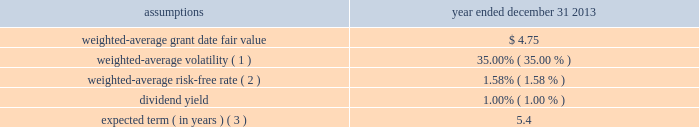Cdw corporation and subsidiaries notes to consolidated financial statements holders of class b common units in connection with the distribution is subject to any vesting provisions previously applicable to the holder 2019s class b common units .
Class b common unit holders received 3798508 shares of restricted stock with respect to class b common units that had not yet vested at the time of the distribution .
For the year ended december 31 , 2013 , 1200544 shares of such restricted stock vested/settled and 5931 shares were forfeited .
As of december 31 , 2013 , 2592033 shares of restricted stock were outstanding .
Stock options in addition , in connection with the ipo , the company issued 1268986 stock options to the class b common unit holders to preserve their fully diluted equity ownership percentage .
These options were issued with a per-share exercise price equal to the ipo price of $ 17.00 and are also subject to the same vesting provisions as the class b common units to which they relate .
The company also granted 19412 stock options under the 2013 ltip during the year ended december 31 , 2013 .
Restricted stock units ( 201crsus 201d ) in connection with the ipo , the company granted 1416543 rsus under the 2013 ltip at a weighted- average grant-date fair value of $ 17.03 per unit .
The rsus cliff-vest at the end of four years .
Valuation information the company attributes the value of equity-based compensation awards to the various periods during which the recipient must perform services in order to vest in the award using the straight-line method .
Post-ipo equity awards the company has elected to use the black-scholes option pricing model to estimate the fair value of stock options granted .
The black-scholes option pricing model incorporates various assumptions including volatility , expected term , risk-free interest rates and dividend yields .
The assumptions used to value the stock options granted during the year ended december 31 , 2013 are presented below .
Year ended december 31 , assumptions 2013 .
Expected term ( in years ) ( 3 ) .
5.4 ( 1 ) based upon an assessment of the two-year , five-year and implied volatility for the company 2019s selected peer group , adjusted for the company 2019s leverage .
( 2 ) based on a composite u.s .
Treasury rate .
( 3 ) the expected term is calculated using the simplified method .
The simplified method defines the expected term as the average of the option 2019s contractual term and the option 2019s weighted-average vesting period .
The company utilizes this method as it has limited historical stock option data that is sufficient to derive a reasonable estimate of the expected stock option term. .
As of dec 13 , 2013 , if all forfeited shares became vested , what percentage of shares would be vested? 
Rationale: add forfeited shares to vested shares , then divide by total shares
Computations: ((5931 + 1200544) / 3798508)
Answer: 0.31762. 